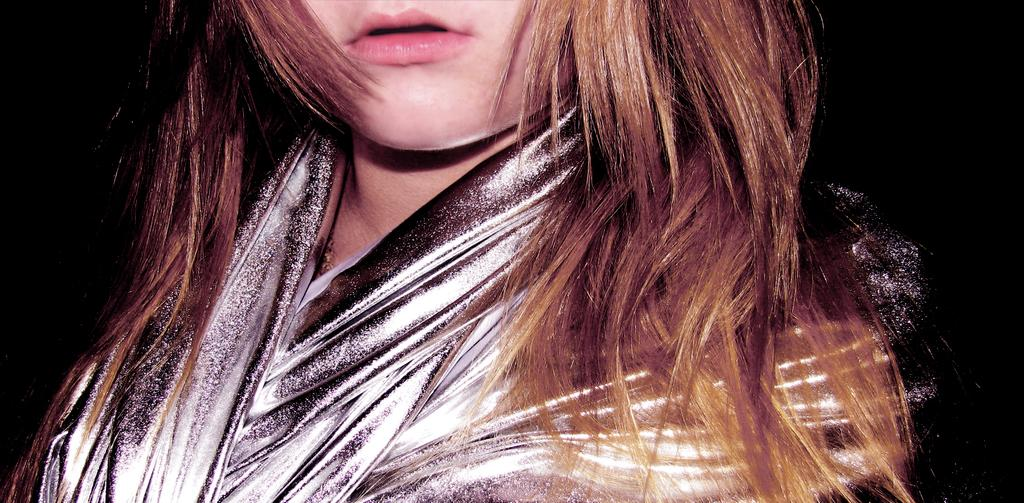Who or what is the main subject in the image? There is a person in the image. What can be observed about the background of the image? The background of the image is dark. How many clovers can be seen growing in the image? There is no mention of clovers or any plants in the image; it only features a person with a dark background. 